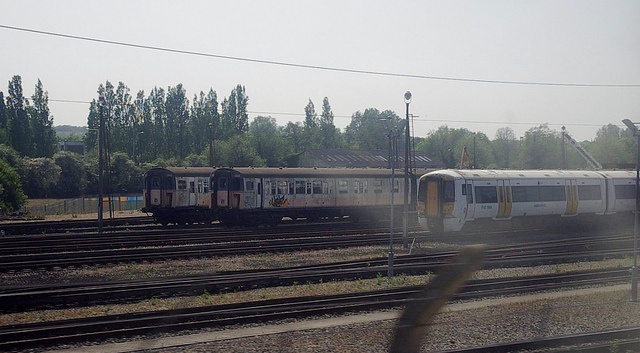Describe the objects in this image and their specific colors. I can see train in lightgray, gray, darkgray, and black tones, train in lightgray, gray, and black tones, and train in lightgray, black, and gray tones in this image. 